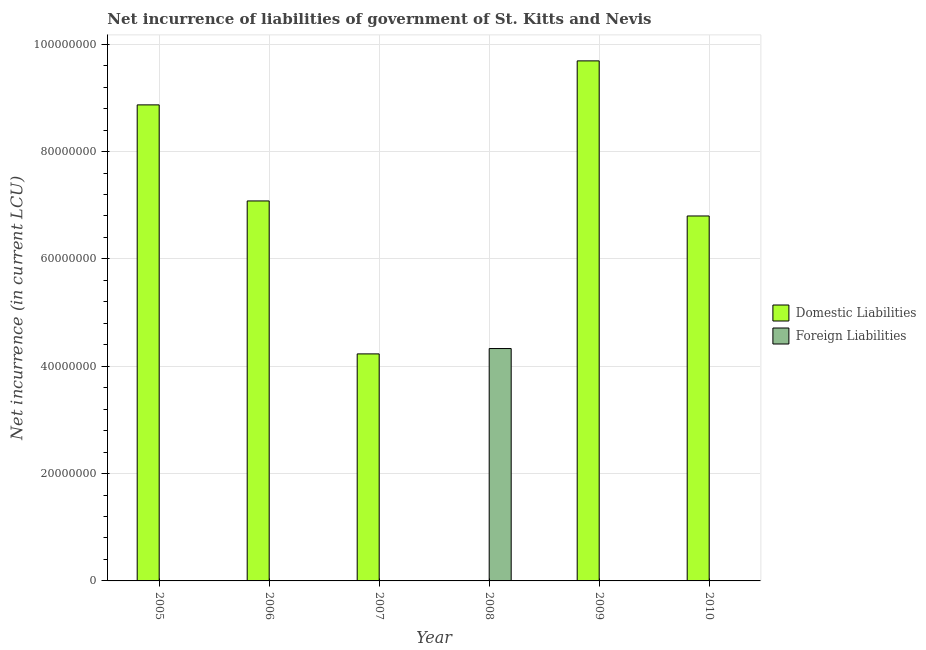Are the number of bars per tick equal to the number of legend labels?
Provide a succinct answer. No. How many bars are there on the 3rd tick from the left?
Offer a terse response. 1. How many bars are there on the 1st tick from the right?
Offer a very short reply. 1. In how many cases, is the number of bars for a given year not equal to the number of legend labels?
Your answer should be very brief. 6. Across all years, what is the maximum net incurrence of domestic liabilities?
Make the answer very short. 9.69e+07. Across all years, what is the minimum net incurrence of foreign liabilities?
Give a very brief answer. 0. What is the total net incurrence of foreign liabilities in the graph?
Keep it short and to the point. 4.33e+07. What is the difference between the net incurrence of domestic liabilities in 2005 and that in 2007?
Your answer should be very brief. 4.64e+07. What is the difference between the net incurrence of domestic liabilities in 2008 and the net incurrence of foreign liabilities in 2007?
Offer a terse response. -4.23e+07. What is the average net incurrence of foreign liabilities per year?
Keep it short and to the point. 7.22e+06. In the year 2006, what is the difference between the net incurrence of domestic liabilities and net incurrence of foreign liabilities?
Offer a terse response. 0. In how many years, is the net incurrence of domestic liabilities greater than 88000000 LCU?
Ensure brevity in your answer.  2. Is the difference between the net incurrence of domestic liabilities in 2005 and 2009 greater than the difference between the net incurrence of foreign liabilities in 2005 and 2009?
Make the answer very short. No. What is the difference between the highest and the second highest net incurrence of domestic liabilities?
Give a very brief answer. 8.20e+06. What is the difference between the highest and the lowest net incurrence of foreign liabilities?
Provide a short and direct response. 4.33e+07. Are all the bars in the graph horizontal?
Your answer should be very brief. No. How many years are there in the graph?
Ensure brevity in your answer.  6. What is the difference between two consecutive major ticks on the Y-axis?
Your answer should be very brief. 2.00e+07. Are the values on the major ticks of Y-axis written in scientific E-notation?
Give a very brief answer. No. How many legend labels are there?
Offer a terse response. 2. How are the legend labels stacked?
Your answer should be very brief. Vertical. What is the title of the graph?
Keep it short and to the point. Net incurrence of liabilities of government of St. Kitts and Nevis. Does "Female entrants" appear as one of the legend labels in the graph?
Provide a short and direct response. No. What is the label or title of the Y-axis?
Make the answer very short. Net incurrence (in current LCU). What is the Net incurrence (in current LCU) of Domestic Liabilities in 2005?
Provide a short and direct response. 8.87e+07. What is the Net incurrence (in current LCU) of Foreign Liabilities in 2005?
Your response must be concise. 0. What is the Net incurrence (in current LCU) in Domestic Liabilities in 2006?
Give a very brief answer. 7.08e+07. What is the Net incurrence (in current LCU) in Foreign Liabilities in 2006?
Provide a succinct answer. 0. What is the Net incurrence (in current LCU) in Domestic Liabilities in 2007?
Give a very brief answer. 4.23e+07. What is the Net incurrence (in current LCU) in Foreign Liabilities in 2007?
Give a very brief answer. 0. What is the Net incurrence (in current LCU) in Foreign Liabilities in 2008?
Provide a short and direct response. 4.33e+07. What is the Net incurrence (in current LCU) of Domestic Liabilities in 2009?
Offer a terse response. 9.69e+07. What is the Net incurrence (in current LCU) of Domestic Liabilities in 2010?
Offer a terse response. 6.80e+07. What is the Net incurrence (in current LCU) of Foreign Liabilities in 2010?
Provide a short and direct response. 0. Across all years, what is the maximum Net incurrence (in current LCU) in Domestic Liabilities?
Offer a very short reply. 9.69e+07. Across all years, what is the maximum Net incurrence (in current LCU) in Foreign Liabilities?
Your answer should be very brief. 4.33e+07. What is the total Net incurrence (in current LCU) of Domestic Liabilities in the graph?
Provide a succinct answer. 3.67e+08. What is the total Net incurrence (in current LCU) of Foreign Liabilities in the graph?
Your response must be concise. 4.33e+07. What is the difference between the Net incurrence (in current LCU) of Domestic Liabilities in 2005 and that in 2006?
Offer a very short reply. 1.79e+07. What is the difference between the Net incurrence (in current LCU) of Domestic Liabilities in 2005 and that in 2007?
Make the answer very short. 4.64e+07. What is the difference between the Net incurrence (in current LCU) in Domestic Liabilities in 2005 and that in 2009?
Your answer should be compact. -8.20e+06. What is the difference between the Net incurrence (in current LCU) of Domestic Liabilities in 2005 and that in 2010?
Your answer should be compact. 2.07e+07. What is the difference between the Net incurrence (in current LCU) in Domestic Liabilities in 2006 and that in 2007?
Your answer should be very brief. 2.85e+07. What is the difference between the Net incurrence (in current LCU) in Domestic Liabilities in 2006 and that in 2009?
Your answer should be very brief. -2.61e+07. What is the difference between the Net incurrence (in current LCU) in Domestic Liabilities in 2006 and that in 2010?
Your response must be concise. 2.80e+06. What is the difference between the Net incurrence (in current LCU) in Domestic Liabilities in 2007 and that in 2009?
Your response must be concise. -5.46e+07. What is the difference between the Net incurrence (in current LCU) in Domestic Liabilities in 2007 and that in 2010?
Keep it short and to the point. -2.57e+07. What is the difference between the Net incurrence (in current LCU) of Domestic Liabilities in 2009 and that in 2010?
Offer a very short reply. 2.89e+07. What is the difference between the Net incurrence (in current LCU) of Domestic Liabilities in 2005 and the Net incurrence (in current LCU) of Foreign Liabilities in 2008?
Your response must be concise. 4.54e+07. What is the difference between the Net incurrence (in current LCU) of Domestic Liabilities in 2006 and the Net incurrence (in current LCU) of Foreign Liabilities in 2008?
Keep it short and to the point. 2.75e+07. What is the average Net incurrence (in current LCU) in Domestic Liabilities per year?
Offer a terse response. 6.11e+07. What is the average Net incurrence (in current LCU) of Foreign Liabilities per year?
Your answer should be compact. 7.22e+06. What is the ratio of the Net incurrence (in current LCU) of Domestic Liabilities in 2005 to that in 2006?
Your answer should be very brief. 1.25. What is the ratio of the Net incurrence (in current LCU) in Domestic Liabilities in 2005 to that in 2007?
Offer a terse response. 2.1. What is the ratio of the Net incurrence (in current LCU) in Domestic Liabilities in 2005 to that in 2009?
Your response must be concise. 0.92. What is the ratio of the Net incurrence (in current LCU) of Domestic Liabilities in 2005 to that in 2010?
Keep it short and to the point. 1.3. What is the ratio of the Net incurrence (in current LCU) in Domestic Liabilities in 2006 to that in 2007?
Make the answer very short. 1.67. What is the ratio of the Net incurrence (in current LCU) of Domestic Liabilities in 2006 to that in 2009?
Your answer should be very brief. 0.73. What is the ratio of the Net incurrence (in current LCU) in Domestic Liabilities in 2006 to that in 2010?
Your answer should be very brief. 1.04. What is the ratio of the Net incurrence (in current LCU) of Domestic Liabilities in 2007 to that in 2009?
Offer a very short reply. 0.44. What is the ratio of the Net incurrence (in current LCU) in Domestic Liabilities in 2007 to that in 2010?
Keep it short and to the point. 0.62. What is the ratio of the Net incurrence (in current LCU) of Domestic Liabilities in 2009 to that in 2010?
Provide a short and direct response. 1.43. What is the difference between the highest and the second highest Net incurrence (in current LCU) of Domestic Liabilities?
Offer a very short reply. 8.20e+06. What is the difference between the highest and the lowest Net incurrence (in current LCU) of Domestic Liabilities?
Offer a very short reply. 9.69e+07. What is the difference between the highest and the lowest Net incurrence (in current LCU) in Foreign Liabilities?
Give a very brief answer. 4.33e+07. 